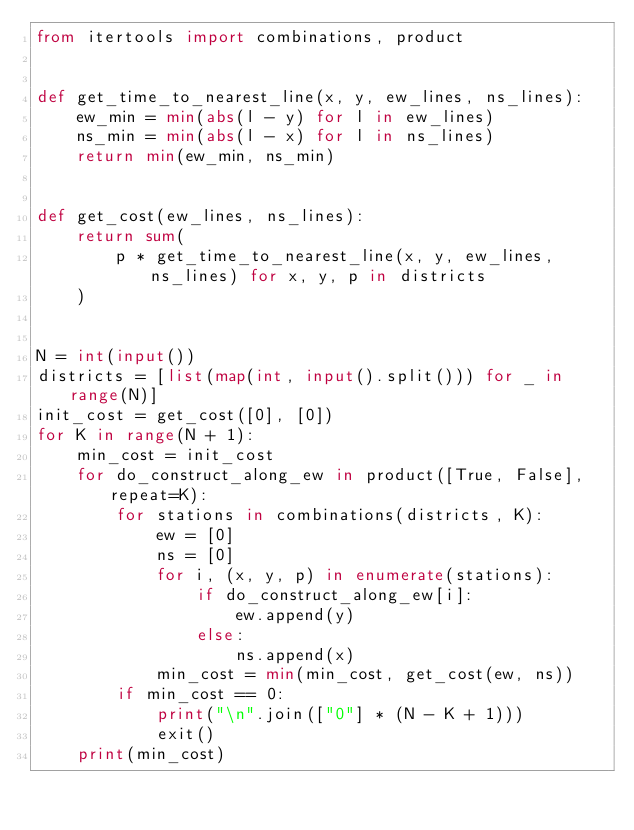Convert code to text. <code><loc_0><loc_0><loc_500><loc_500><_Python_>from itertools import combinations, product


def get_time_to_nearest_line(x, y, ew_lines, ns_lines):
    ew_min = min(abs(l - y) for l in ew_lines)
    ns_min = min(abs(l - x) for l in ns_lines)
    return min(ew_min, ns_min)


def get_cost(ew_lines, ns_lines):
    return sum(
        p * get_time_to_nearest_line(x, y, ew_lines, ns_lines) for x, y, p in districts
    )


N = int(input())
districts = [list(map(int, input().split())) for _ in range(N)]
init_cost = get_cost([0], [0])
for K in range(N + 1):
    min_cost = init_cost
    for do_construct_along_ew in product([True, False], repeat=K):
        for stations in combinations(districts, K):
            ew = [0]
            ns = [0]
            for i, (x, y, p) in enumerate(stations):
                if do_construct_along_ew[i]:
                    ew.append(y)
                else:
                    ns.append(x)
            min_cost = min(min_cost, get_cost(ew, ns))
        if min_cost == 0:
            print("\n".join(["0"] * (N - K + 1)))
            exit()
    print(min_cost)
</code> 